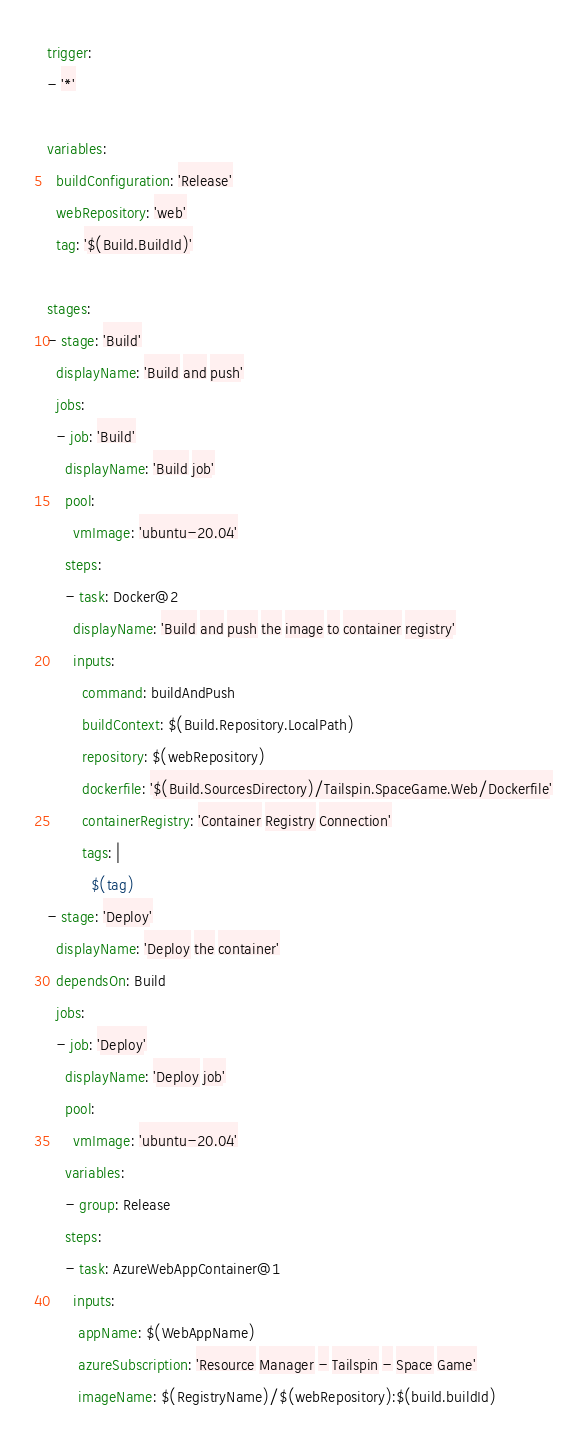<code> <loc_0><loc_0><loc_500><loc_500><_YAML_>trigger:
- '*'

variables:
  buildConfiguration: 'Release'
  webRepository: 'web'
  tag: '$(Build.BuildId)'

stages:
- stage: 'Build'
  displayName: 'Build and push'
  jobs:  
  - job: 'Build'
    displayName: 'Build job'
    pool:
      vmImage: 'ubuntu-20.04'
    steps:
    - task: Docker@2
      displayName: 'Build and push the image to container registry'
      inputs:
        command: buildAndPush
        buildContext: $(Build.Repository.LocalPath)
        repository: $(webRepository)
        dockerfile: '$(Build.SourcesDirectory)/Tailspin.SpaceGame.Web/Dockerfile'
        containerRegistry: 'Container Registry Connection'
        tags: |
          $(tag)
- stage: 'Deploy'
  displayName: 'Deploy the container'
  dependsOn: Build
  jobs:
  - job: 'Deploy'
    displayName: 'Deploy job'
    pool:
      vmImage: 'ubuntu-20.04'
    variables:
    - group: Release
    steps:
    - task: AzureWebAppContainer@1
      inputs:
       appName: $(WebAppName)
       azureSubscription: 'Resource Manager - Tailspin - Space Game'
       imageName: $(RegistryName)/$(webRepository):$(build.buildId)</code> 